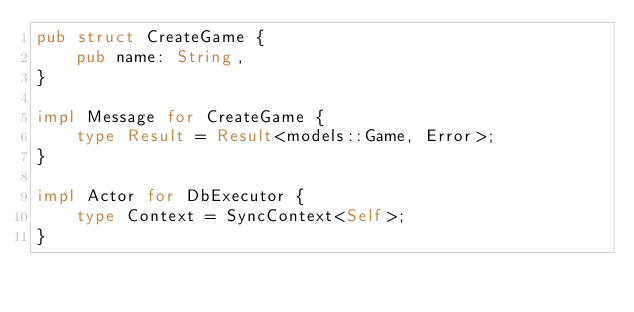Convert code to text. <code><loc_0><loc_0><loc_500><loc_500><_Rust_>pub struct CreateGame {
    pub name: String,
}

impl Message for CreateGame {
    type Result = Result<models::Game, Error>;
}

impl Actor for DbExecutor {
    type Context = SyncContext<Self>;
}
</code> 